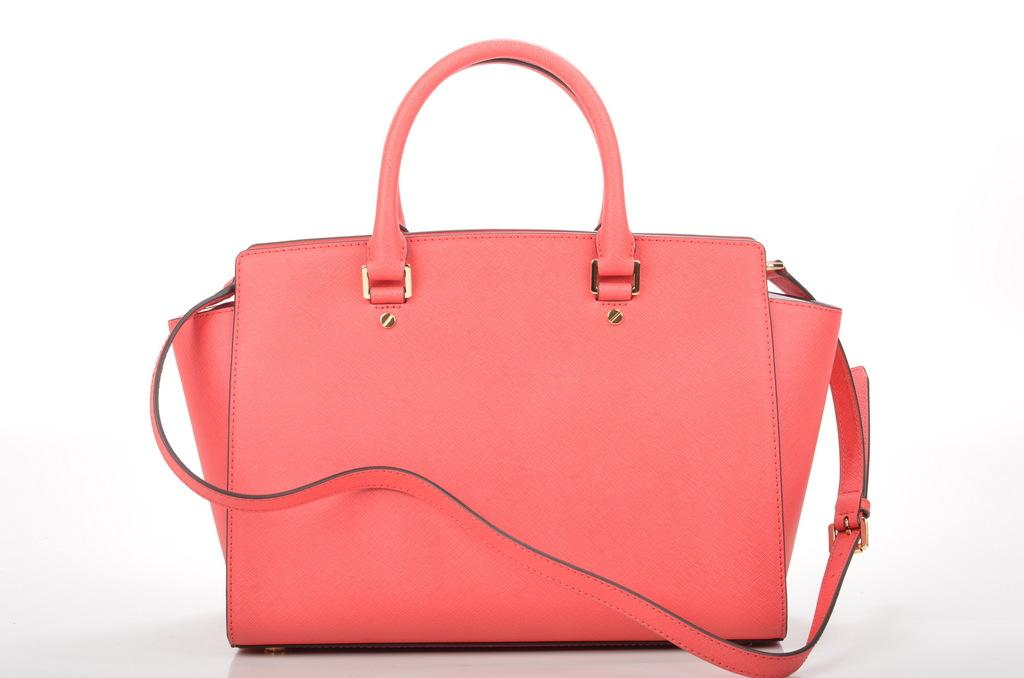What object can be seen in the image? There is a bag in the image. What color is the bag? The bag is pink in color. How many chairs are depicted in the image? There are no chairs present in the image; it only features a pink bag. What type of art is displayed on the bag? There is no art displayed on the bag; it is simply a pink bag. 